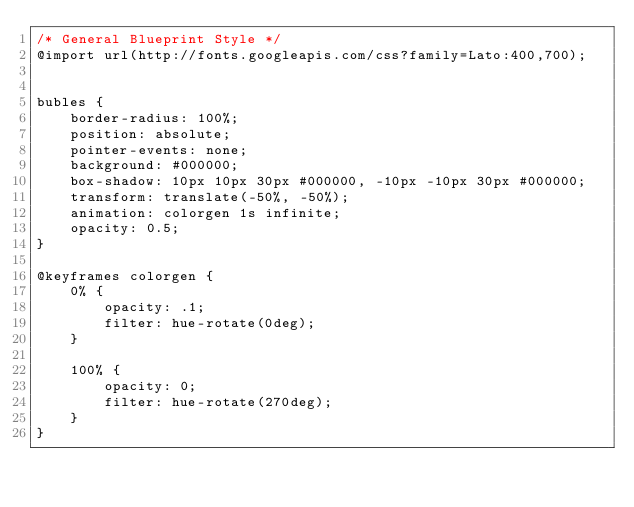<code> <loc_0><loc_0><loc_500><loc_500><_CSS_>/* General Blueprint Style */
@import url(http://fonts.googleapis.com/css?family=Lato:400,700);


bubles {
    border-radius: 100%;
    position: absolute;
    pointer-events: none;
    background: #000000;
    box-shadow: 10px 10px 30px #000000, -10px -10px 30px #000000;
    transform: translate(-50%, -50%);
    animation: colorgen 1s infinite;
    opacity: 0.5;
}

@keyframes colorgen {
    0% {
        opacity: .1;
        filter: hue-rotate(0deg);
    }

    100% {
        opacity: 0;
        filter: hue-rotate(270deg);
    }
}


</code> 